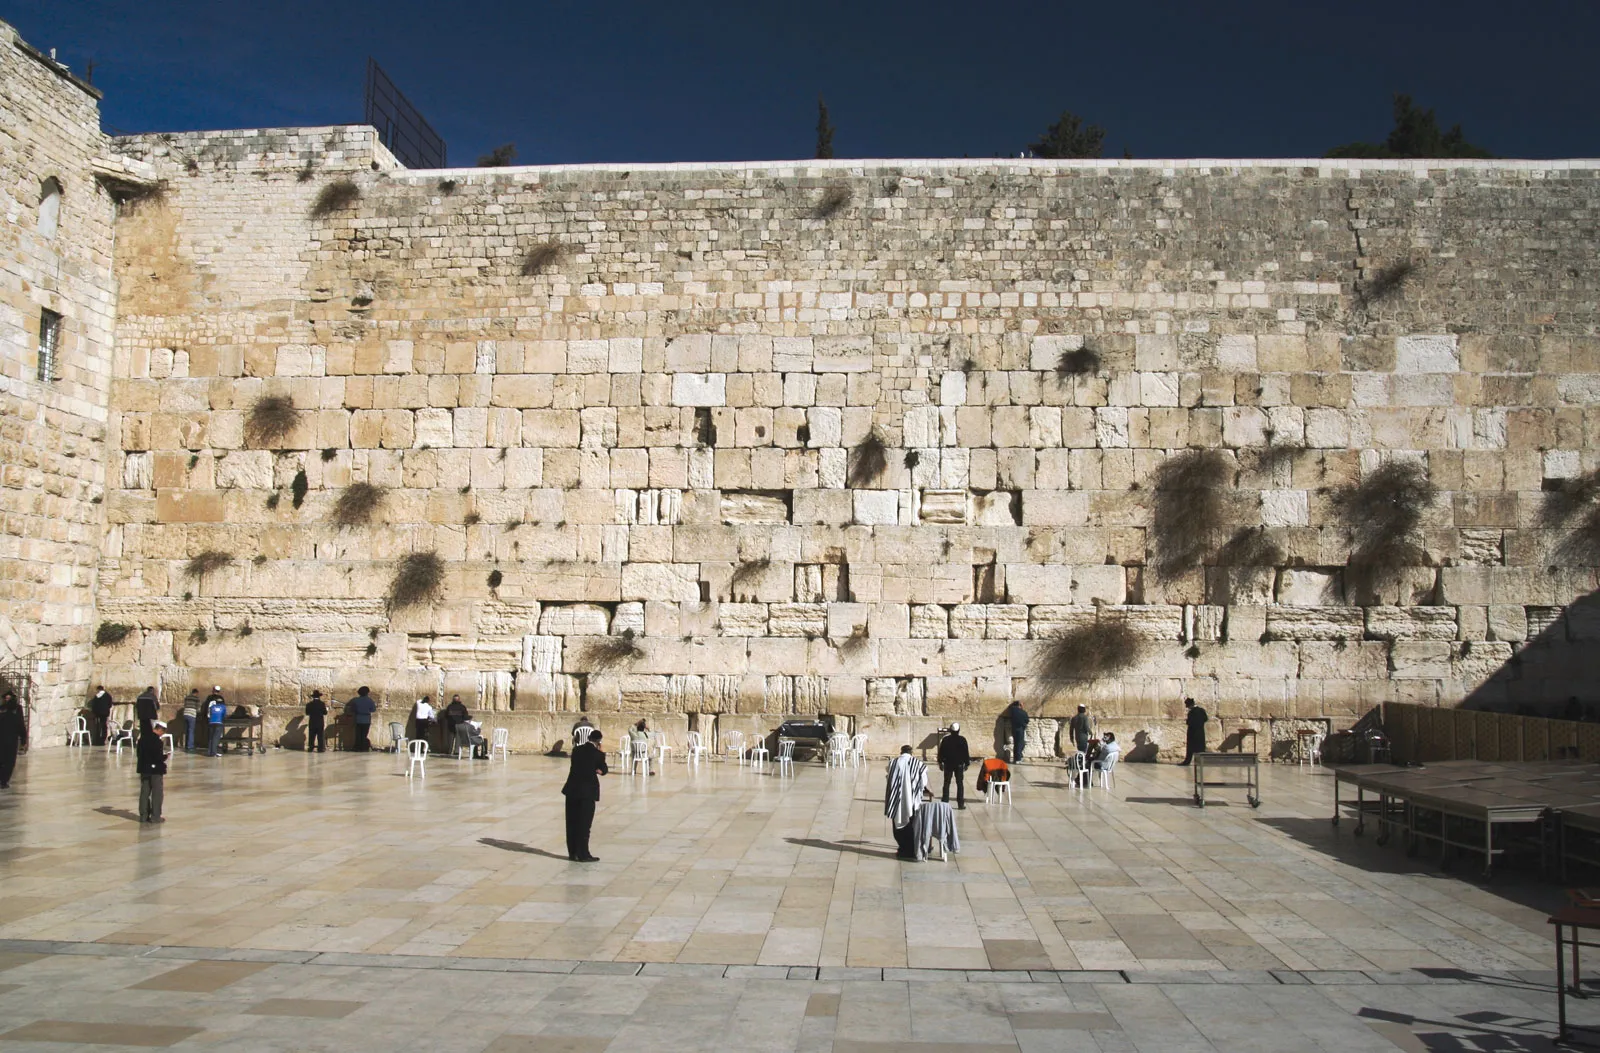Can you explain the attire worn by some individuals in front of the wall? Many individuals near the wall wear distinctive orthodox Jewish attire, which often includes black suits and white shirts for men, accompanied by a kippah or sometimes a larger hat known as a shtreimel. This traditional dress signifies modesty and reverence in accordance with religious teachings. Women, when present in the vicinity, often adopt modest attire as well, including long skirts and covered shoulders, aligning with orthodox norms for modesty.  Why are some men wearing different hats, and what do they signify? The variety in hat styles among men at the Wall often reflects their specific religious or Hassidic sect. For instance, the shtreimel is particularly worn by married men from certain Hassidic communities on Sabbaths and holidays, symbolizing both spiritual joy and respect. Others may wear a black velvet or knitted kippah, which signifies their devotion and serves as a constant reminder of their faith. 